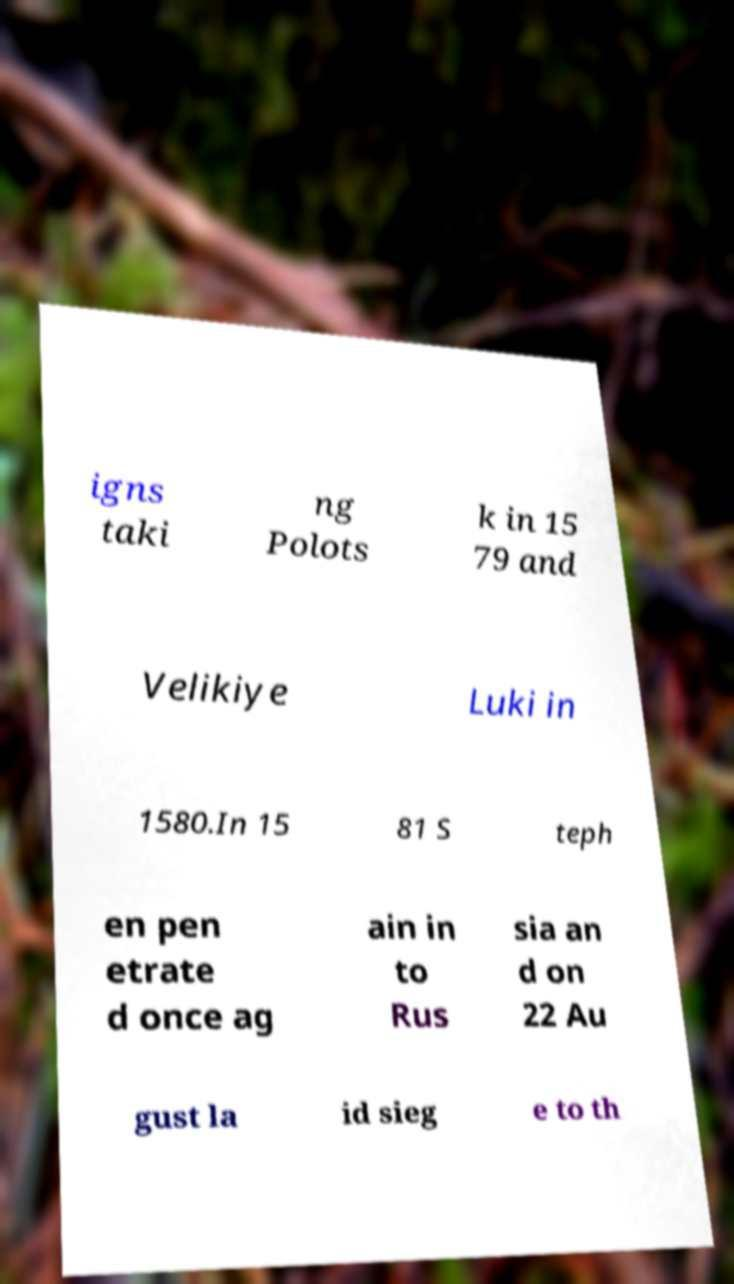Please identify and transcribe the text found in this image. igns taki ng Polots k in 15 79 and Velikiye Luki in 1580.In 15 81 S teph en pen etrate d once ag ain in to Rus sia an d on 22 Au gust la id sieg e to th 